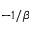<formula> <loc_0><loc_0><loc_500><loc_500>- 1 / \beta</formula> 